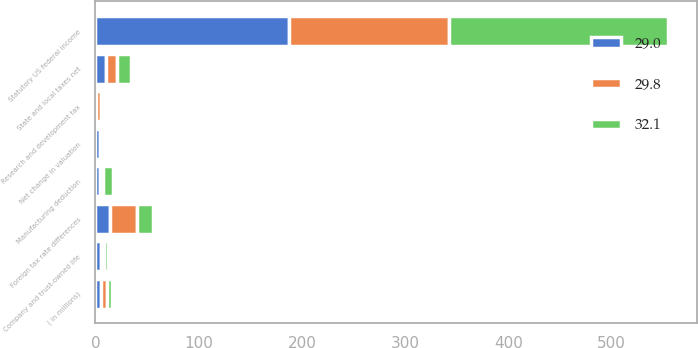<chart> <loc_0><loc_0><loc_500><loc_500><stacked_bar_chart><ecel><fcel>( in millions)<fcel>Statutory US federal income<fcel>Foreign tax rate differences<fcel>Company and trust-owned life<fcel>Research and development tax<fcel>Manufacturing deduction<fcel>Net change in valuation<fcel>State and local taxes net<nl><fcel>32.1<fcel>5.4<fcel>212.2<fcel>15<fcel>4.6<fcel>1.2<fcel>9.7<fcel>1.8<fcel>13.1<nl><fcel>29<fcel>5.4<fcel>187.8<fcel>14.3<fcel>5.4<fcel>0.9<fcel>4<fcel>4.5<fcel>10.7<nl><fcel>29.8<fcel>5.4<fcel>155<fcel>26.2<fcel>2.5<fcel>4.9<fcel>3.3<fcel>1.8<fcel>10.4<nl></chart> 